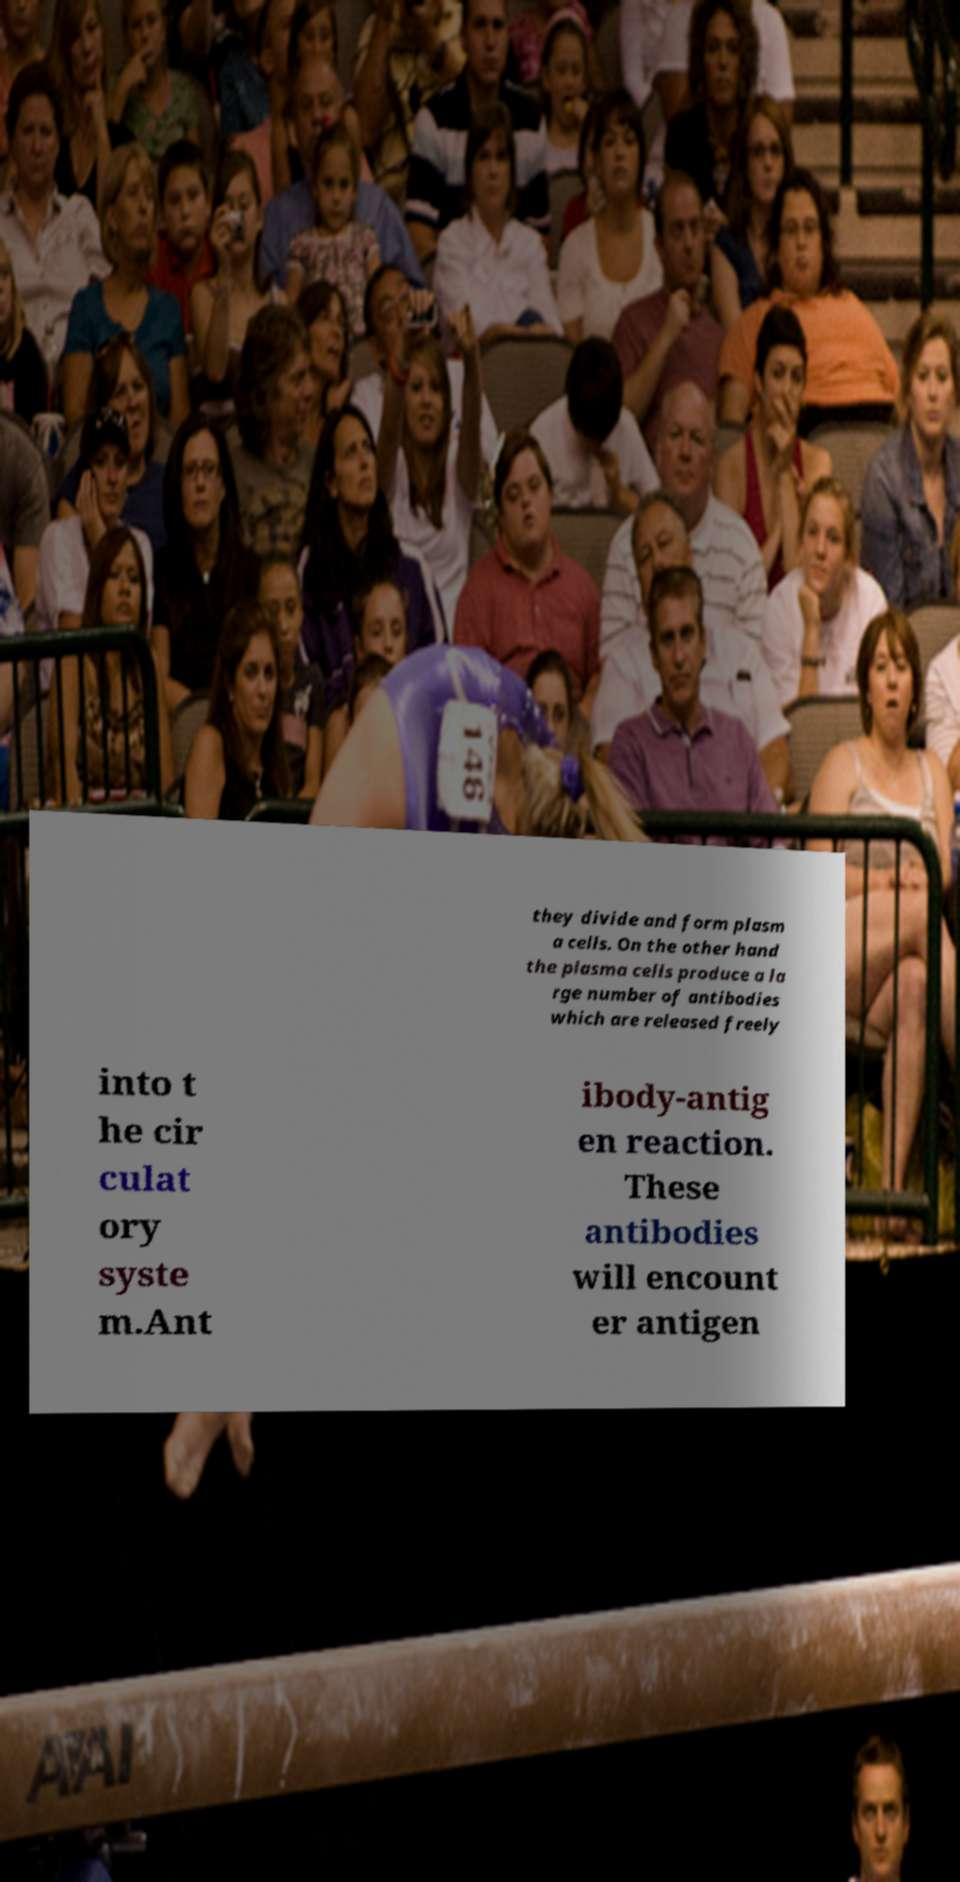Could you extract and type out the text from this image? they divide and form plasm a cells. On the other hand the plasma cells produce a la rge number of antibodies which are released freely into t he cir culat ory syste m.Ant ibody-antig en reaction. These antibodies will encount er antigen 